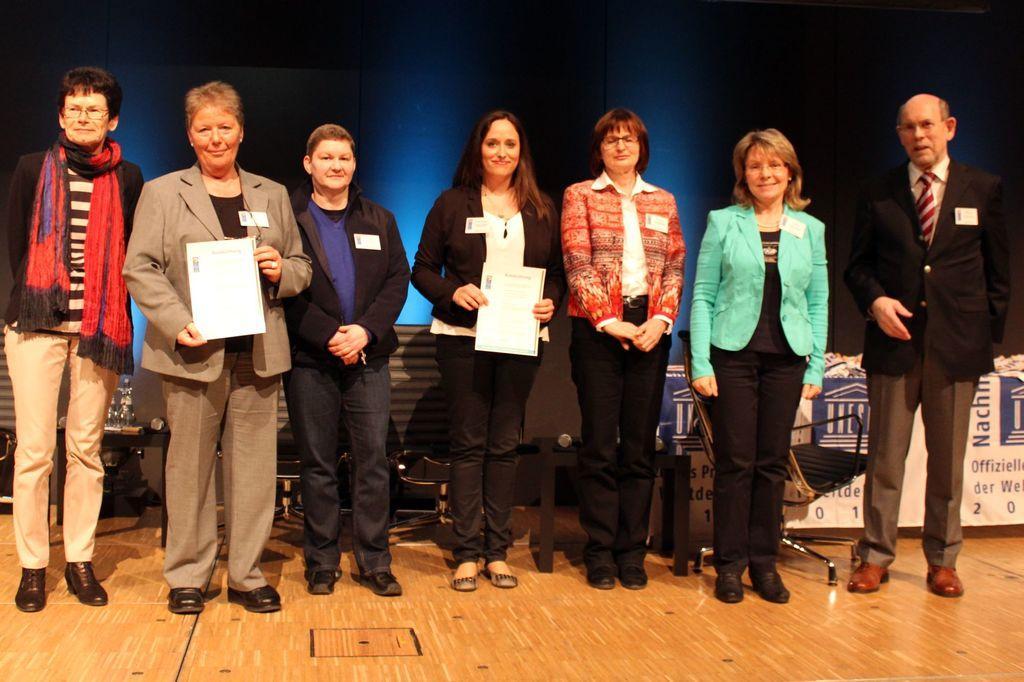How would you summarize this image in a sentence or two? In this picture we can see people standing on the floor. We can see two women holding certificates and smiling. We can see a dark blue background. We can see chairs, objects and a banner. 